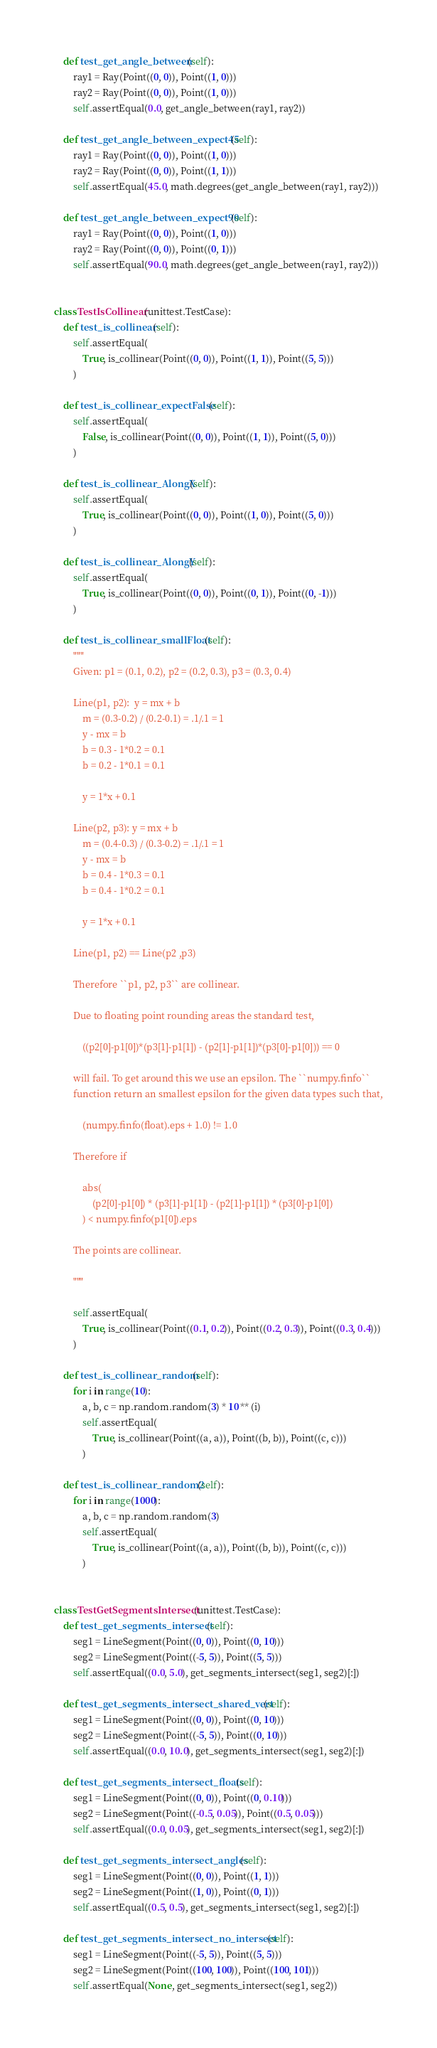Convert code to text. <code><loc_0><loc_0><loc_500><loc_500><_Python_>    def test_get_angle_between(self):
        ray1 = Ray(Point((0, 0)), Point((1, 0)))
        ray2 = Ray(Point((0, 0)), Point((1, 0)))
        self.assertEqual(0.0, get_angle_between(ray1, ray2))

    def test_get_angle_between_expect45(self):
        ray1 = Ray(Point((0, 0)), Point((1, 0)))
        ray2 = Ray(Point((0, 0)), Point((1, 1)))
        self.assertEqual(45.0, math.degrees(get_angle_between(ray1, ray2)))

    def test_get_angle_between_expect90(self):
        ray1 = Ray(Point((0, 0)), Point((1, 0)))
        ray2 = Ray(Point((0, 0)), Point((0, 1)))
        self.assertEqual(90.0, math.degrees(get_angle_between(ray1, ray2)))


class TestIsCollinear(unittest.TestCase):
    def test_is_collinear(self):
        self.assertEqual(
            True, is_collinear(Point((0, 0)), Point((1, 1)), Point((5, 5)))
        )

    def test_is_collinear_expectFalse(self):
        self.assertEqual(
            False, is_collinear(Point((0, 0)), Point((1, 1)), Point((5, 0)))
        )

    def test_is_collinear_AlongX(self):
        self.assertEqual(
            True, is_collinear(Point((0, 0)), Point((1, 0)), Point((5, 0)))
        )

    def test_is_collinear_AlongY(self):
        self.assertEqual(
            True, is_collinear(Point((0, 0)), Point((0, 1)), Point((0, -1)))
        )

    def test_is_collinear_smallFloat(self):
        """
        Given: p1 = (0.1, 0.2), p2 = (0.2, 0.3), p3 = (0.3, 0.4)

        Line(p1, p2):  y = mx + b
            m = (0.3-0.2) / (0.2-0.1) = .1/.1 = 1
            y - mx = b
            b = 0.3 - 1*0.2 = 0.1
            b = 0.2 - 1*0.1 = 0.1

            y = 1*x + 0.1

        Line(p2, p3): y = mx + b
            m = (0.4-0.3) / (0.3-0.2) = .1/.1 = 1
            y - mx = b
            b = 0.4 - 1*0.3 = 0.1
            b = 0.4 - 1*0.2 = 0.1

            y = 1*x + 0.1

        Line(p1, p2) == Line(p2 ,p3)
        
        Therefore ``p1, p2, p3`` are collinear.

        Due to floating point rounding areas the standard test,
        
            ((p2[0]-p1[0])*(p3[1]-p1[1]) - (p2[1]-p1[1])*(p3[0]-p1[0])) == 0
        
        will fail. To get around this we use an epsilon. The ``numpy.finfo``
        function return an smallest epsilon for the given data types such that,
        
            (numpy.finfo(float).eps + 1.0) != 1.0

        Therefore if
        
            abs(
                (p2[0]-p1[0]) * (p3[1]-p1[1]) - (p2[1]-p1[1]) * (p3[0]-p1[0])
            ) < numpy.finfo(p1[0]).eps
        
        The points are collinear.
        
        """

        self.assertEqual(
            True, is_collinear(Point((0.1, 0.2)), Point((0.2, 0.3)), Point((0.3, 0.4)))
        )

    def test_is_collinear_random(self):
        for i in range(10):
            a, b, c = np.random.random(3) * 10 ** (i)
            self.assertEqual(
                True, is_collinear(Point((a, a)), Point((b, b)), Point((c, c)))
            )

    def test_is_collinear_random2(self):
        for i in range(1000):
            a, b, c = np.random.random(3)
            self.assertEqual(
                True, is_collinear(Point((a, a)), Point((b, b)), Point((c, c)))
            )


class TestGetSegmentsIntersect(unittest.TestCase):
    def test_get_segments_intersect(self):
        seg1 = LineSegment(Point((0, 0)), Point((0, 10)))
        seg2 = LineSegment(Point((-5, 5)), Point((5, 5)))
        self.assertEqual((0.0, 5.0), get_segments_intersect(seg1, seg2)[:])

    def test_get_segments_intersect_shared_vert(self):
        seg1 = LineSegment(Point((0, 0)), Point((0, 10)))
        seg2 = LineSegment(Point((-5, 5)), Point((0, 10)))
        self.assertEqual((0.0, 10.0), get_segments_intersect(seg1, seg2)[:])

    def test_get_segments_intersect_floats(self):
        seg1 = LineSegment(Point((0, 0)), Point((0, 0.10)))
        seg2 = LineSegment(Point((-0.5, 0.05)), Point((0.5, 0.05)))
        self.assertEqual((0.0, 0.05), get_segments_intersect(seg1, seg2)[:])

    def test_get_segments_intersect_angles(self):
        seg1 = LineSegment(Point((0, 0)), Point((1, 1)))
        seg2 = LineSegment(Point((1, 0)), Point((0, 1)))
        self.assertEqual((0.5, 0.5), get_segments_intersect(seg1, seg2)[:])

    def test_get_segments_intersect_no_intersect(self):
        seg1 = LineSegment(Point((-5, 5)), Point((5, 5)))
        seg2 = LineSegment(Point((100, 100)), Point((100, 101)))
        self.assertEqual(None, get_segments_intersect(seg1, seg2))
</code> 